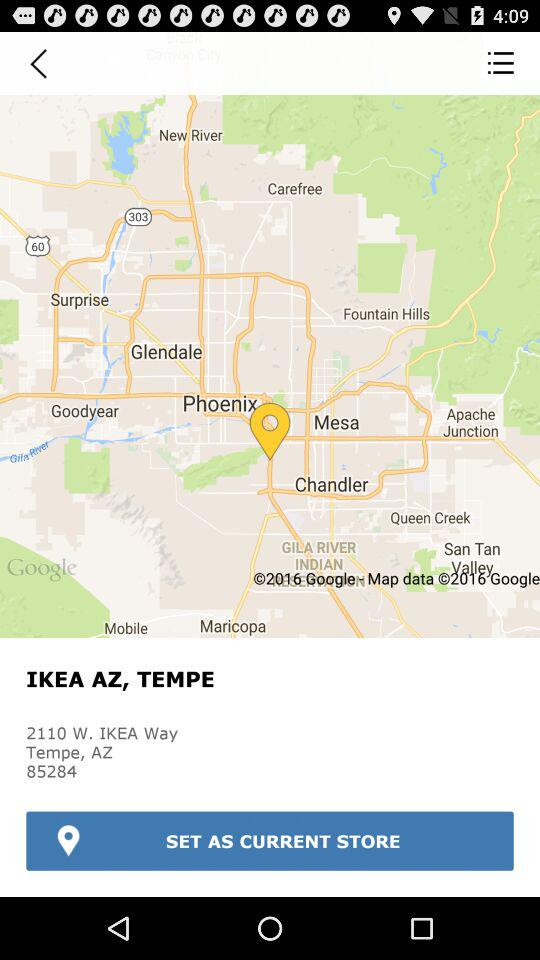What is the name of the store? The name of the store is "IKEA". 